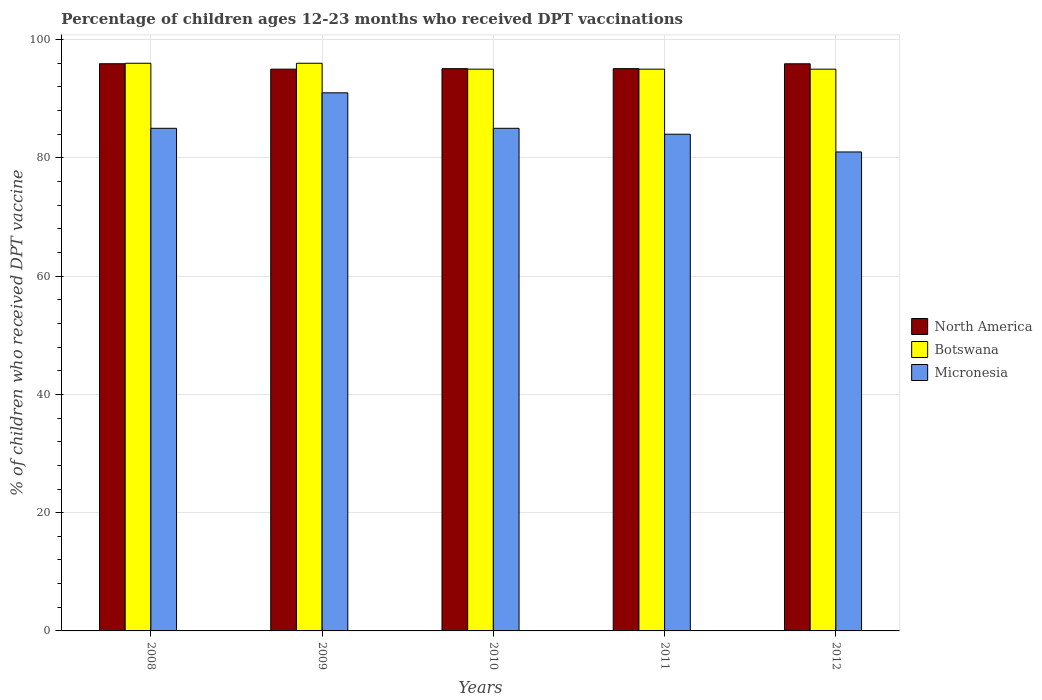Are the number of bars on each tick of the X-axis equal?
Make the answer very short. Yes. How many bars are there on the 3rd tick from the left?
Make the answer very short. 3. How many bars are there on the 5th tick from the right?
Give a very brief answer. 3. What is the label of the 3rd group of bars from the left?
Ensure brevity in your answer.  2010. Across all years, what is the maximum percentage of children who received DPT vaccination in North America?
Ensure brevity in your answer.  95.92. Across all years, what is the minimum percentage of children who received DPT vaccination in Micronesia?
Provide a short and direct response. 81. In which year was the percentage of children who received DPT vaccination in Botswana maximum?
Ensure brevity in your answer.  2008. In which year was the percentage of children who received DPT vaccination in Micronesia minimum?
Your response must be concise. 2012. What is the total percentage of children who received DPT vaccination in Botswana in the graph?
Your answer should be very brief. 477. What is the difference between the percentage of children who received DPT vaccination in Botswana in 2008 and that in 2010?
Keep it short and to the point. 1. What is the average percentage of children who received DPT vaccination in Botswana per year?
Your answer should be very brief. 95.4. In the year 2012, what is the difference between the percentage of children who received DPT vaccination in Botswana and percentage of children who received DPT vaccination in North America?
Your answer should be very brief. -0.91. In how many years, is the percentage of children who received DPT vaccination in Botswana greater than 72 %?
Your answer should be very brief. 5. What is the ratio of the percentage of children who received DPT vaccination in North America in 2008 to that in 2009?
Provide a succinct answer. 1.01. Is the percentage of children who received DPT vaccination in Micronesia in 2010 less than that in 2011?
Provide a short and direct response. No. Is the difference between the percentage of children who received DPT vaccination in Botswana in 2009 and 2010 greater than the difference between the percentage of children who received DPT vaccination in North America in 2009 and 2010?
Your response must be concise. Yes. What is the difference between the highest and the lowest percentage of children who received DPT vaccination in Botswana?
Ensure brevity in your answer.  1. What does the 2nd bar from the left in 2008 represents?
Your answer should be very brief. Botswana. Is it the case that in every year, the sum of the percentage of children who received DPT vaccination in Botswana and percentage of children who received DPT vaccination in North America is greater than the percentage of children who received DPT vaccination in Micronesia?
Ensure brevity in your answer.  Yes. How many bars are there?
Your answer should be compact. 15. How many years are there in the graph?
Keep it short and to the point. 5. Are the values on the major ticks of Y-axis written in scientific E-notation?
Keep it short and to the point. No. Does the graph contain grids?
Provide a succinct answer. Yes. Where does the legend appear in the graph?
Give a very brief answer. Center right. What is the title of the graph?
Your response must be concise. Percentage of children ages 12-23 months who received DPT vaccinations. What is the label or title of the Y-axis?
Provide a short and direct response. % of children who received DPT vaccine. What is the % of children who received DPT vaccine of North America in 2008?
Keep it short and to the point. 95.92. What is the % of children who received DPT vaccine of Botswana in 2008?
Ensure brevity in your answer.  96. What is the % of children who received DPT vaccine of Micronesia in 2008?
Provide a succinct answer. 85. What is the % of children who received DPT vaccine in North America in 2009?
Offer a terse response. 95. What is the % of children who received DPT vaccine in Botswana in 2009?
Keep it short and to the point. 96. What is the % of children who received DPT vaccine in Micronesia in 2009?
Ensure brevity in your answer.  91. What is the % of children who received DPT vaccine in North America in 2010?
Your response must be concise. 95.09. What is the % of children who received DPT vaccine in Micronesia in 2010?
Make the answer very short. 85. What is the % of children who received DPT vaccine of North America in 2011?
Provide a short and direct response. 95.09. What is the % of children who received DPT vaccine in North America in 2012?
Keep it short and to the point. 95.91. What is the % of children who received DPT vaccine in Micronesia in 2012?
Ensure brevity in your answer.  81. Across all years, what is the maximum % of children who received DPT vaccine of North America?
Give a very brief answer. 95.92. Across all years, what is the maximum % of children who received DPT vaccine in Botswana?
Make the answer very short. 96. Across all years, what is the maximum % of children who received DPT vaccine of Micronesia?
Ensure brevity in your answer.  91. Across all years, what is the minimum % of children who received DPT vaccine of North America?
Your answer should be compact. 95. Across all years, what is the minimum % of children who received DPT vaccine of Botswana?
Provide a succinct answer. 95. What is the total % of children who received DPT vaccine of North America in the graph?
Your response must be concise. 477. What is the total % of children who received DPT vaccine in Botswana in the graph?
Give a very brief answer. 477. What is the total % of children who received DPT vaccine in Micronesia in the graph?
Make the answer very short. 426. What is the difference between the % of children who received DPT vaccine of North America in 2008 and that in 2009?
Offer a terse response. 0.92. What is the difference between the % of children who received DPT vaccine of North America in 2008 and that in 2010?
Keep it short and to the point. 0.83. What is the difference between the % of children who received DPT vaccine in Botswana in 2008 and that in 2010?
Make the answer very short. 1. What is the difference between the % of children who received DPT vaccine in Micronesia in 2008 and that in 2010?
Make the answer very short. 0. What is the difference between the % of children who received DPT vaccine in North America in 2008 and that in 2011?
Offer a terse response. 0.83. What is the difference between the % of children who received DPT vaccine in Botswana in 2008 and that in 2011?
Make the answer very short. 1. What is the difference between the % of children who received DPT vaccine of Micronesia in 2008 and that in 2011?
Offer a very short reply. 1. What is the difference between the % of children who received DPT vaccine of North America in 2008 and that in 2012?
Keep it short and to the point. 0.01. What is the difference between the % of children who received DPT vaccine in Botswana in 2008 and that in 2012?
Provide a short and direct response. 1. What is the difference between the % of children who received DPT vaccine of North America in 2009 and that in 2010?
Provide a short and direct response. -0.09. What is the difference between the % of children who received DPT vaccine of Botswana in 2009 and that in 2010?
Your response must be concise. 1. What is the difference between the % of children who received DPT vaccine of Micronesia in 2009 and that in 2010?
Give a very brief answer. 6. What is the difference between the % of children who received DPT vaccine of North America in 2009 and that in 2011?
Give a very brief answer. -0.09. What is the difference between the % of children who received DPT vaccine in Micronesia in 2009 and that in 2011?
Offer a terse response. 7. What is the difference between the % of children who received DPT vaccine in North America in 2009 and that in 2012?
Offer a terse response. -0.91. What is the difference between the % of children who received DPT vaccine of Botswana in 2009 and that in 2012?
Provide a short and direct response. 1. What is the difference between the % of children who received DPT vaccine of Micronesia in 2009 and that in 2012?
Give a very brief answer. 10. What is the difference between the % of children who received DPT vaccine in North America in 2010 and that in 2011?
Give a very brief answer. -0. What is the difference between the % of children who received DPT vaccine in Micronesia in 2010 and that in 2011?
Provide a short and direct response. 1. What is the difference between the % of children who received DPT vaccine in North America in 2010 and that in 2012?
Your answer should be compact. -0.82. What is the difference between the % of children who received DPT vaccine of Micronesia in 2010 and that in 2012?
Your answer should be compact. 4. What is the difference between the % of children who received DPT vaccine of North America in 2011 and that in 2012?
Your answer should be very brief. -0.82. What is the difference between the % of children who received DPT vaccine in North America in 2008 and the % of children who received DPT vaccine in Botswana in 2009?
Offer a very short reply. -0.08. What is the difference between the % of children who received DPT vaccine of North America in 2008 and the % of children who received DPT vaccine of Micronesia in 2009?
Offer a very short reply. 4.92. What is the difference between the % of children who received DPT vaccine of North America in 2008 and the % of children who received DPT vaccine of Botswana in 2010?
Your answer should be compact. 0.92. What is the difference between the % of children who received DPT vaccine of North America in 2008 and the % of children who received DPT vaccine of Micronesia in 2010?
Keep it short and to the point. 10.92. What is the difference between the % of children who received DPT vaccine of Botswana in 2008 and the % of children who received DPT vaccine of Micronesia in 2010?
Give a very brief answer. 11. What is the difference between the % of children who received DPT vaccine in North America in 2008 and the % of children who received DPT vaccine in Botswana in 2011?
Provide a succinct answer. 0.92. What is the difference between the % of children who received DPT vaccine of North America in 2008 and the % of children who received DPT vaccine of Micronesia in 2011?
Keep it short and to the point. 11.92. What is the difference between the % of children who received DPT vaccine of North America in 2008 and the % of children who received DPT vaccine of Botswana in 2012?
Offer a terse response. 0.92. What is the difference between the % of children who received DPT vaccine of North America in 2008 and the % of children who received DPT vaccine of Micronesia in 2012?
Ensure brevity in your answer.  14.92. What is the difference between the % of children who received DPT vaccine in Botswana in 2008 and the % of children who received DPT vaccine in Micronesia in 2012?
Provide a short and direct response. 15. What is the difference between the % of children who received DPT vaccine of Botswana in 2009 and the % of children who received DPT vaccine of Micronesia in 2010?
Provide a short and direct response. 11. What is the difference between the % of children who received DPT vaccine in North America in 2009 and the % of children who received DPT vaccine in Micronesia in 2011?
Keep it short and to the point. 11. What is the difference between the % of children who received DPT vaccine in North America in 2009 and the % of children who received DPT vaccine in Micronesia in 2012?
Your response must be concise. 14. What is the difference between the % of children who received DPT vaccine of Botswana in 2009 and the % of children who received DPT vaccine of Micronesia in 2012?
Offer a terse response. 15. What is the difference between the % of children who received DPT vaccine in North America in 2010 and the % of children who received DPT vaccine in Botswana in 2011?
Ensure brevity in your answer.  0.09. What is the difference between the % of children who received DPT vaccine in North America in 2010 and the % of children who received DPT vaccine in Micronesia in 2011?
Provide a short and direct response. 11.09. What is the difference between the % of children who received DPT vaccine in Botswana in 2010 and the % of children who received DPT vaccine in Micronesia in 2011?
Offer a terse response. 11. What is the difference between the % of children who received DPT vaccine of North America in 2010 and the % of children who received DPT vaccine of Botswana in 2012?
Provide a short and direct response. 0.09. What is the difference between the % of children who received DPT vaccine of North America in 2010 and the % of children who received DPT vaccine of Micronesia in 2012?
Ensure brevity in your answer.  14.09. What is the difference between the % of children who received DPT vaccine of Botswana in 2010 and the % of children who received DPT vaccine of Micronesia in 2012?
Offer a terse response. 14. What is the difference between the % of children who received DPT vaccine in North America in 2011 and the % of children who received DPT vaccine in Botswana in 2012?
Your answer should be very brief. 0.09. What is the difference between the % of children who received DPT vaccine of North America in 2011 and the % of children who received DPT vaccine of Micronesia in 2012?
Make the answer very short. 14.09. What is the difference between the % of children who received DPT vaccine of Botswana in 2011 and the % of children who received DPT vaccine of Micronesia in 2012?
Give a very brief answer. 14. What is the average % of children who received DPT vaccine in North America per year?
Provide a succinct answer. 95.4. What is the average % of children who received DPT vaccine of Botswana per year?
Offer a very short reply. 95.4. What is the average % of children who received DPT vaccine of Micronesia per year?
Offer a terse response. 85.2. In the year 2008, what is the difference between the % of children who received DPT vaccine in North America and % of children who received DPT vaccine in Botswana?
Keep it short and to the point. -0.08. In the year 2008, what is the difference between the % of children who received DPT vaccine of North America and % of children who received DPT vaccine of Micronesia?
Your answer should be very brief. 10.92. In the year 2008, what is the difference between the % of children who received DPT vaccine in Botswana and % of children who received DPT vaccine in Micronesia?
Offer a very short reply. 11. In the year 2009, what is the difference between the % of children who received DPT vaccine of North America and % of children who received DPT vaccine of Botswana?
Give a very brief answer. -1. In the year 2009, what is the difference between the % of children who received DPT vaccine of Botswana and % of children who received DPT vaccine of Micronesia?
Offer a very short reply. 5. In the year 2010, what is the difference between the % of children who received DPT vaccine of North America and % of children who received DPT vaccine of Botswana?
Offer a terse response. 0.09. In the year 2010, what is the difference between the % of children who received DPT vaccine in North America and % of children who received DPT vaccine in Micronesia?
Ensure brevity in your answer.  10.09. In the year 2011, what is the difference between the % of children who received DPT vaccine in North America and % of children who received DPT vaccine in Botswana?
Provide a succinct answer. 0.09. In the year 2011, what is the difference between the % of children who received DPT vaccine in North America and % of children who received DPT vaccine in Micronesia?
Give a very brief answer. 11.09. In the year 2012, what is the difference between the % of children who received DPT vaccine of North America and % of children who received DPT vaccine of Botswana?
Make the answer very short. 0.91. In the year 2012, what is the difference between the % of children who received DPT vaccine in North America and % of children who received DPT vaccine in Micronesia?
Keep it short and to the point. 14.91. What is the ratio of the % of children who received DPT vaccine in North America in 2008 to that in 2009?
Give a very brief answer. 1.01. What is the ratio of the % of children who received DPT vaccine in Botswana in 2008 to that in 2009?
Your answer should be very brief. 1. What is the ratio of the % of children who received DPT vaccine of Micronesia in 2008 to that in 2009?
Offer a very short reply. 0.93. What is the ratio of the % of children who received DPT vaccine of North America in 2008 to that in 2010?
Provide a succinct answer. 1.01. What is the ratio of the % of children who received DPT vaccine in Botswana in 2008 to that in 2010?
Your answer should be very brief. 1.01. What is the ratio of the % of children who received DPT vaccine of Micronesia in 2008 to that in 2010?
Ensure brevity in your answer.  1. What is the ratio of the % of children who received DPT vaccine in North America in 2008 to that in 2011?
Ensure brevity in your answer.  1.01. What is the ratio of the % of children who received DPT vaccine in Botswana in 2008 to that in 2011?
Give a very brief answer. 1.01. What is the ratio of the % of children who received DPT vaccine of Micronesia in 2008 to that in 2011?
Ensure brevity in your answer.  1.01. What is the ratio of the % of children who received DPT vaccine in Botswana in 2008 to that in 2012?
Your answer should be very brief. 1.01. What is the ratio of the % of children who received DPT vaccine in Micronesia in 2008 to that in 2012?
Offer a terse response. 1.05. What is the ratio of the % of children who received DPT vaccine of North America in 2009 to that in 2010?
Provide a short and direct response. 1. What is the ratio of the % of children who received DPT vaccine in Botswana in 2009 to that in 2010?
Provide a short and direct response. 1.01. What is the ratio of the % of children who received DPT vaccine in Micronesia in 2009 to that in 2010?
Give a very brief answer. 1.07. What is the ratio of the % of children who received DPT vaccine of Botswana in 2009 to that in 2011?
Provide a succinct answer. 1.01. What is the ratio of the % of children who received DPT vaccine in North America in 2009 to that in 2012?
Offer a terse response. 0.99. What is the ratio of the % of children who received DPT vaccine in Botswana in 2009 to that in 2012?
Provide a succinct answer. 1.01. What is the ratio of the % of children who received DPT vaccine in Micronesia in 2009 to that in 2012?
Offer a very short reply. 1.12. What is the ratio of the % of children who received DPT vaccine of North America in 2010 to that in 2011?
Give a very brief answer. 1. What is the ratio of the % of children who received DPT vaccine in Micronesia in 2010 to that in 2011?
Offer a very short reply. 1.01. What is the ratio of the % of children who received DPT vaccine of Botswana in 2010 to that in 2012?
Provide a short and direct response. 1. What is the ratio of the % of children who received DPT vaccine of Micronesia in 2010 to that in 2012?
Make the answer very short. 1.05. What is the ratio of the % of children who received DPT vaccine in North America in 2011 to that in 2012?
Keep it short and to the point. 0.99. What is the ratio of the % of children who received DPT vaccine in Botswana in 2011 to that in 2012?
Provide a succinct answer. 1. What is the difference between the highest and the second highest % of children who received DPT vaccine of North America?
Make the answer very short. 0.01. What is the difference between the highest and the second highest % of children who received DPT vaccine in Botswana?
Keep it short and to the point. 0. What is the difference between the highest and the second highest % of children who received DPT vaccine of Micronesia?
Your answer should be compact. 6. What is the difference between the highest and the lowest % of children who received DPT vaccine of North America?
Offer a terse response. 0.92. 